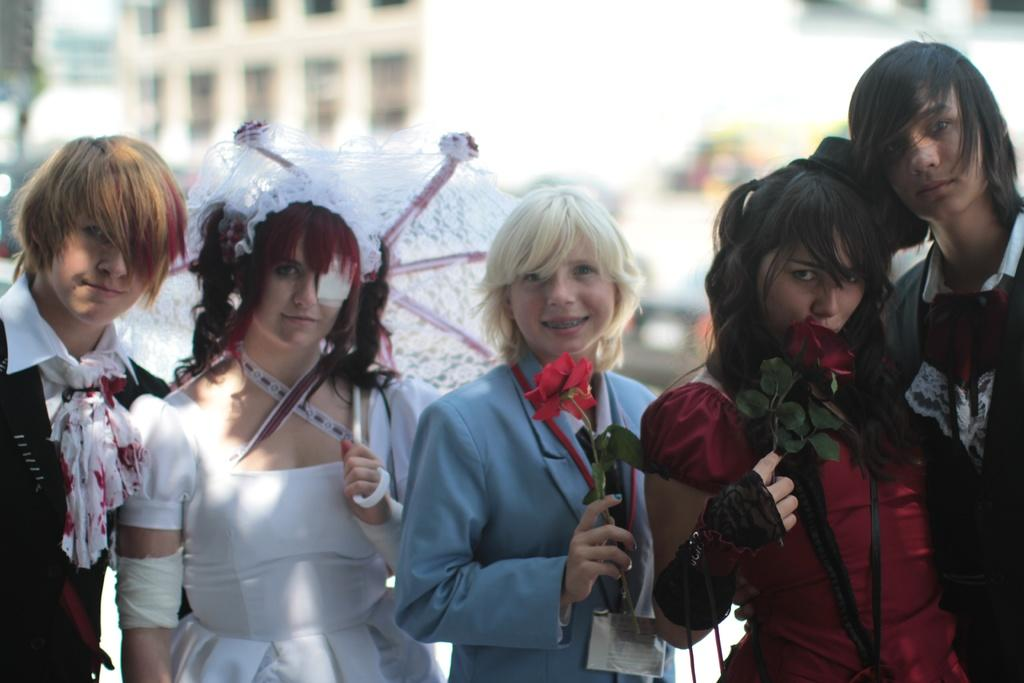What are the people in the image doing? The people in the image are standing. What are the people wearing? The people are wearing different color dresses. What objects are the people holding in the image? The people are holding umbrellas and roses. What can be seen in the background of the image? There is a building visible in the background of the image. What type of wool is being used to make the swimsuits in the image? There is no swimsuit or wool present in the image; the people are wearing dresses and holding umbrellas and roses. 